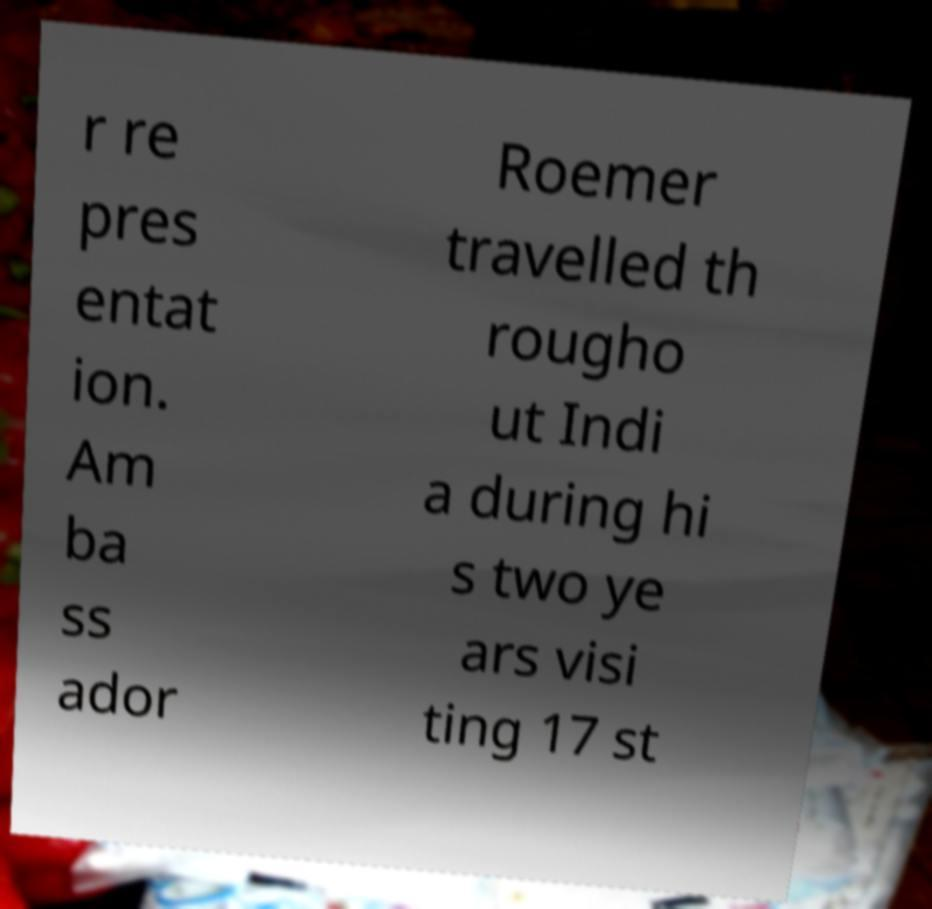Can you accurately transcribe the text from the provided image for me? r re pres entat ion. Am ba ss ador Roemer travelled th rougho ut Indi a during hi s two ye ars visi ting 17 st 